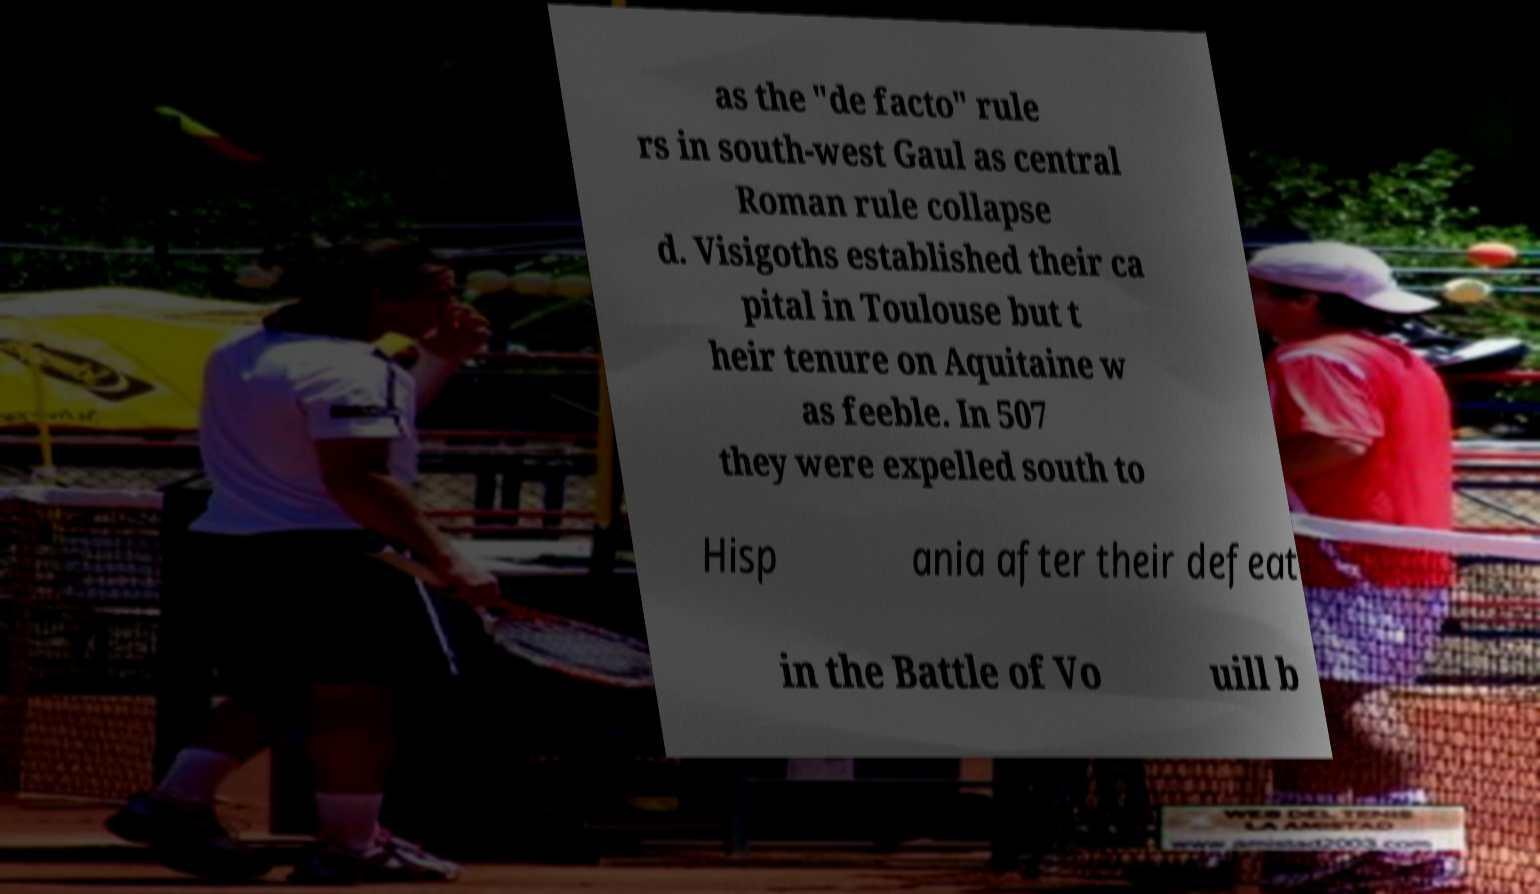Can you read and provide the text displayed in the image?This photo seems to have some interesting text. Can you extract and type it out for me? as the "de facto" rule rs in south-west Gaul as central Roman rule collapse d. Visigoths established their ca pital in Toulouse but t heir tenure on Aquitaine w as feeble. In 507 they were expelled south to Hisp ania after their defeat in the Battle of Vo uill b 